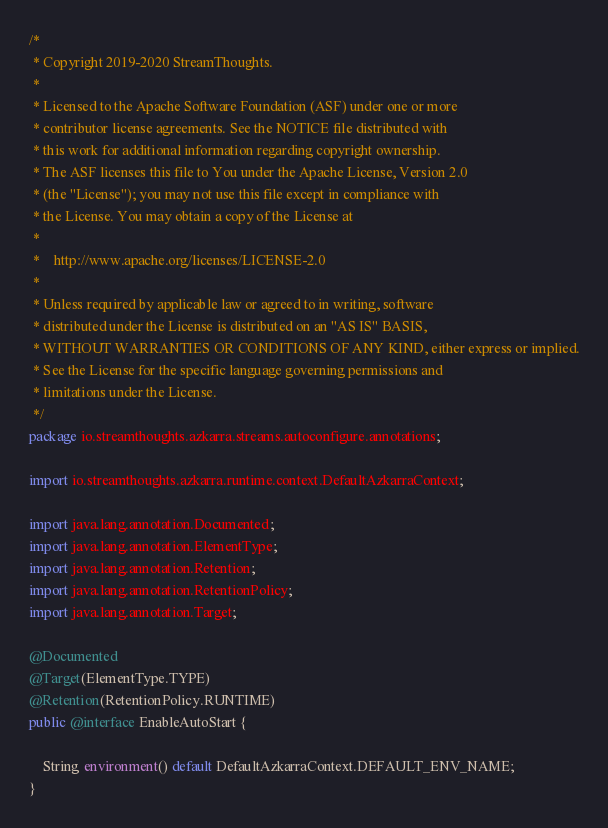Convert code to text. <code><loc_0><loc_0><loc_500><loc_500><_Java_>/*
 * Copyright 2019-2020 StreamThoughts.
 *
 * Licensed to the Apache Software Foundation (ASF) under one or more
 * contributor license agreements. See the NOTICE file distributed with
 * this work for additional information regarding copyright ownership.
 * The ASF licenses this file to You under the Apache License, Version 2.0
 * (the "License"); you may not use this file except in compliance with
 * the License. You may obtain a copy of the License at
 *
 *    http://www.apache.org/licenses/LICENSE-2.0
 *
 * Unless required by applicable law or agreed to in writing, software
 * distributed under the License is distributed on an "AS IS" BASIS,
 * WITHOUT WARRANTIES OR CONDITIONS OF ANY KIND, either express or implied.
 * See the License for the specific language governing permissions and
 * limitations under the License.
 */
package io.streamthoughts.azkarra.streams.autoconfigure.annotations;

import io.streamthoughts.azkarra.runtime.context.DefaultAzkarraContext;

import java.lang.annotation.Documented;
import java.lang.annotation.ElementType;
import java.lang.annotation.Retention;
import java.lang.annotation.RetentionPolicy;
import java.lang.annotation.Target;

@Documented
@Target(ElementType.TYPE)
@Retention(RetentionPolicy.RUNTIME)
public @interface EnableAutoStart {

    String environment() default DefaultAzkarraContext.DEFAULT_ENV_NAME;
}
</code> 